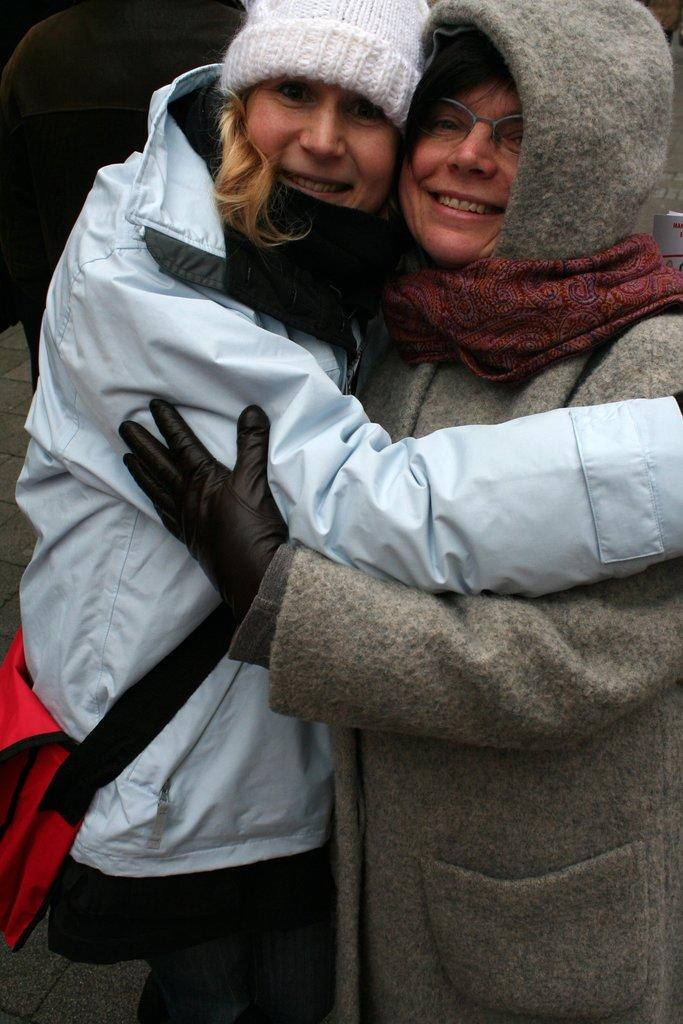What can be seen in the image? There is a group of people in the image. Can you describe the woman in the image? There is a woman in the image, and she is on the left side. What is the woman wearing on her head? The woman is wearing a cap. What is the woman holding in the image? The woman is carrying a bag. What type of bomb is the woman carrying in the image? There is no bomb present in the image; the woman is carrying a bag. What punishment is being given to the woman in the image? There is no indication of punishment in the image; the woman is simply part of a group of people. 